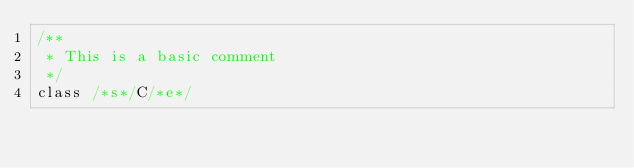<code> <loc_0><loc_0><loc_500><loc_500><_Scala_>/**
 * This is a basic comment
 */
class /*s*/C/*e*/
</code> 